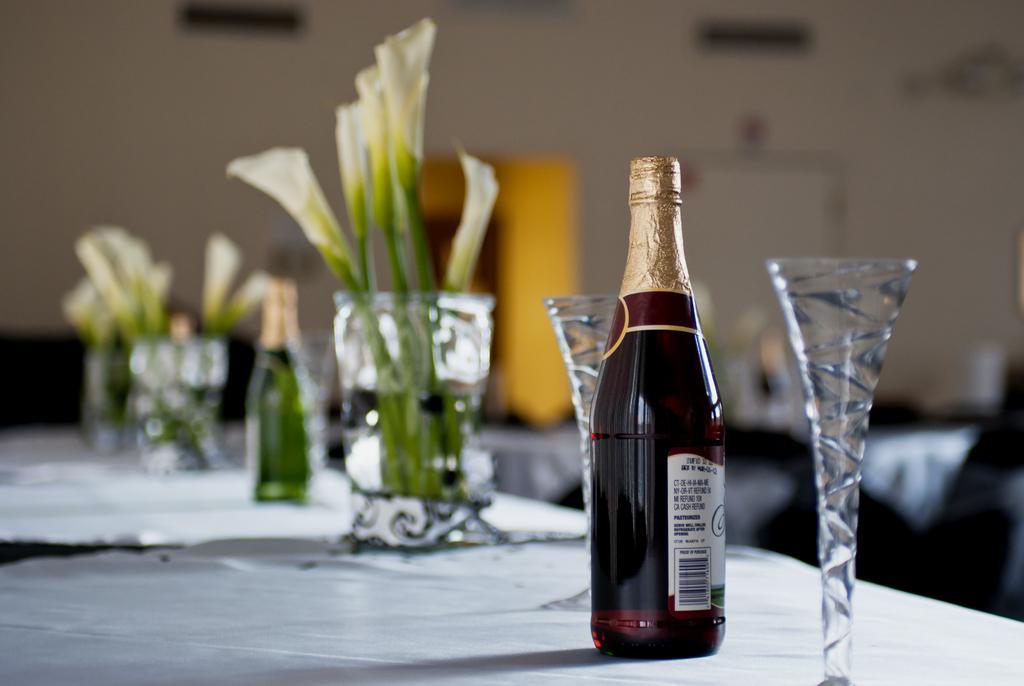Can you describe this image briefly? In this picture we can see bottles, glasses on the platform, here we can see plants and in the background we can see a wall and some objects. 